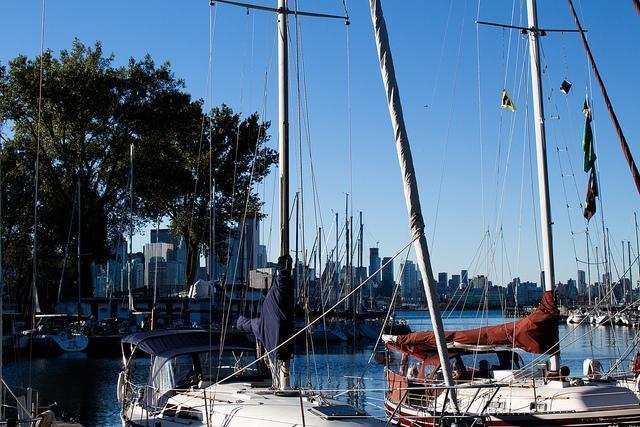How many of these boats have their sails unfurled?
Give a very brief answer. 0. How many boats are there?
Give a very brief answer. 2. 